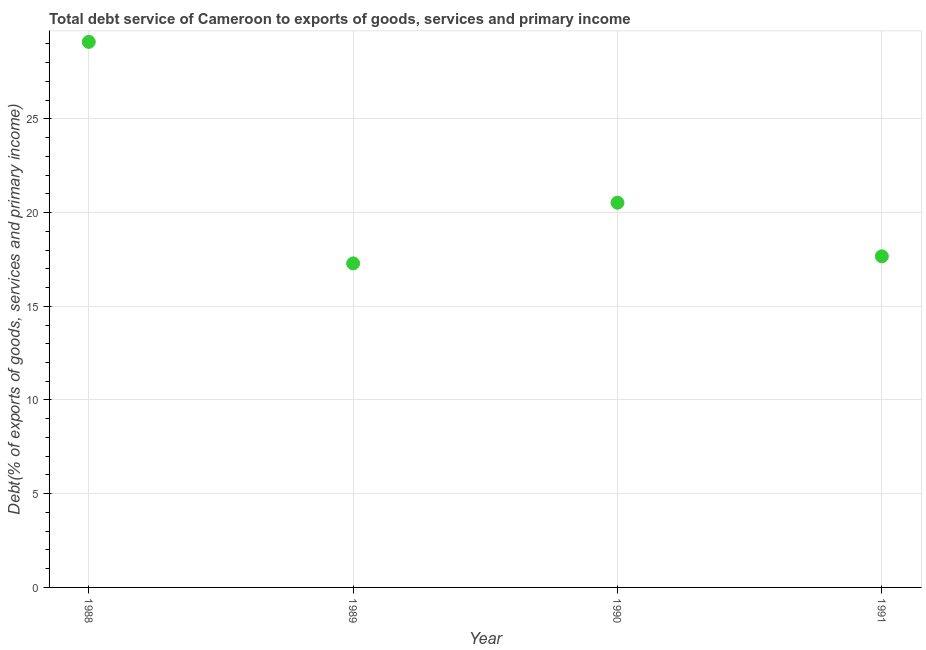What is the total debt service in 1989?
Your response must be concise. 17.29. Across all years, what is the maximum total debt service?
Provide a succinct answer. 29.1. Across all years, what is the minimum total debt service?
Offer a terse response. 17.29. In which year was the total debt service minimum?
Give a very brief answer. 1989. What is the sum of the total debt service?
Offer a very short reply. 84.58. What is the difference between the total debt service in 1990 and 1991?
Make the answer very short. 2.86. What is the average total debt service per year?
Provide a short and direct response. 21.14. What is the median total debt service?
Your answer should be compact. 19.09. Do a majority of the years between 1988 and 1989 (inclusive) have total debt service greater than 17 %?
Provide a succinct answer. Yes. What is the ratio of the total debt service in 1989 to that in 1991?
Provide a succinct answer. 0.98. Is the total debt service in 1989 less than that in 1990?
Offer a terse response. Yes. Is the difference between the total debt service in 1990 and 1991 greater than the difference between any two years?
Make the answer very short. No. What is the difference between the highest and the second highest total debt service?
Your answer should be very brief. 8.58. Is the sum of the total debt service in 1988 and 1989 greater than the maximum total debt service across all years?
Provide a short and direct response. Yes. What is the difference between the highest and the lowest total debt service?
Your answer should be very brief. 11.82. In how many years, is the total debt service greater than the average total debt service taken over all years?
Offer a very short reply. 1. How many years are there in the graph?
Keep it short and to the point. 4. Does the graph contain grids?
Keep it short and to the point. Yes. What is the title of the graph?
Make the answer very short. Total debt service of Cameroon to exports of goods, services and primary income. What is the label or title of the X-axis?
Ensure brevity in your answer.  Year. What is the label or title of the Y-axis?
Provide a succinct answer. Debt(% of exports of goods, services and primary income). What is the Debt(% of exports of goods, services and primary income) in 1988?
Provide a succinct answer. 29.1. What is the Debt(% of exports of goods, services and primary income) in 1989?
Offer a terse response. 17.29. What is the Debt(% of exports of goods, services and primary income) in 1990?
Provide a short and direct response. 20.52. What is the Debt(% of exports of goods, services and primary income) in 1991?
Provide a succinct answer. 17.66. What is the difference between the Debt(% of exports of goods, services and primary income) in 1988 and 1989?
Provide a succinct answer. 11.82. What is the difference between the Debt(% of exports of goods, services and primary income) in 1988 and 1990?
Offer a very short reply. 8.58. What is the difference between the Debt(% of exports of goods, services and primary income) in 1988 and 1991?
Your answer should be very brief. 11.44. What is the difference between the Debt(% of exports of goods, services and primary income) in 1989 and 1990?
Offer a terse response. -3.24. What is the difference between the Debt(% of exports of goods, services and primary income) in 1989 and 1991?
Make the answer very short. -0.38. What is the difference between the Debt(% of exports of goods, services and primary income) in 1990 and 1991?
Give a very brief answer. 2.86. What is the ratio of the Debt(% of exports of goods, services and primary income) in 1988 to that in 1989?
Keep it short and to the point. 1.68. What is the ratio of the Debt(% of exports of goods, services and primary income) in 1988 to that in 1990?
Your answer should be very brief. 1.42. What is the ratio of the Debt(% of exports of goods, services and primary income) in 1988 to that in 1991?
Offer a terse response. 1.65. What is the ratio of the Debt(% of exports of goods, services and primary income) in 1989 to that in 1990?
Make the answer very short. 0.84. What is the ratio of the Debt(% of exports of goods, services and primary income) in 1989 to that in 1991?
Your answer should be compact. 0.98. What is the ratio of the Debt(% of exports of goods, services and primary income) in 1990 to that in 1991?
Your answer should be compact. 1.16. 